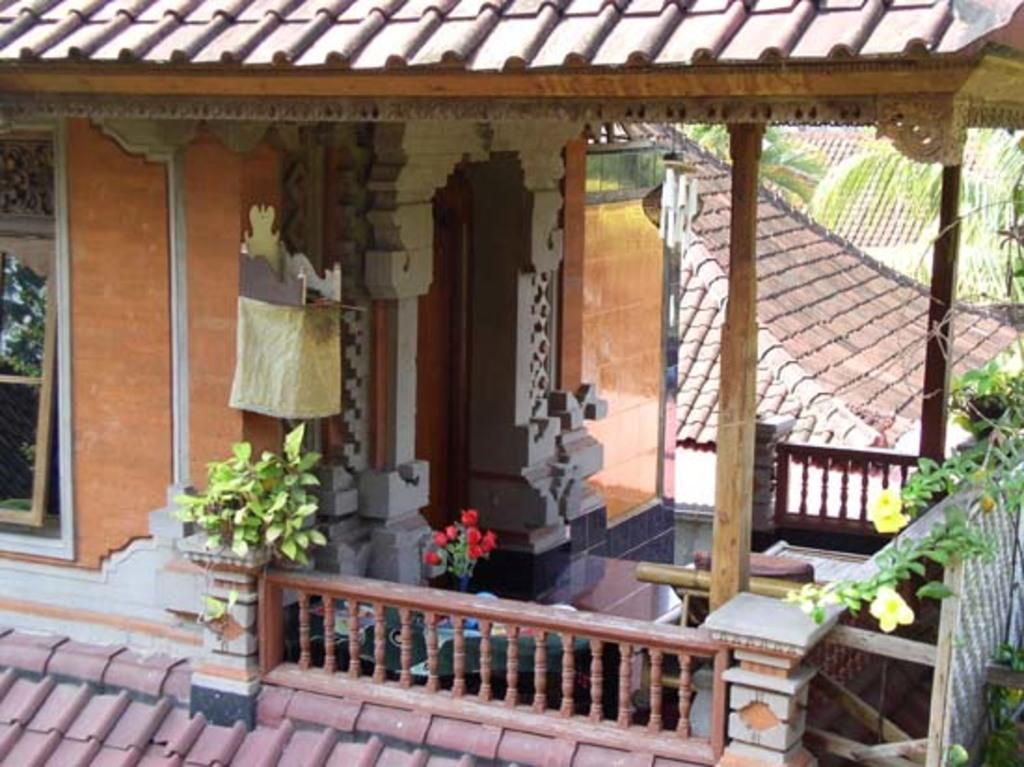What type of structures are present in the image? There are houses in the image. What features can be observed on the houses? The houses have roofs and windows. What type of vegetation is present in the image? There is a tree and plants with flowers in the image. What direction is the quiet stem facing in the image? There is no stem or direction mentioned in the image; it only features houses, a tree, and plants with flowers. 